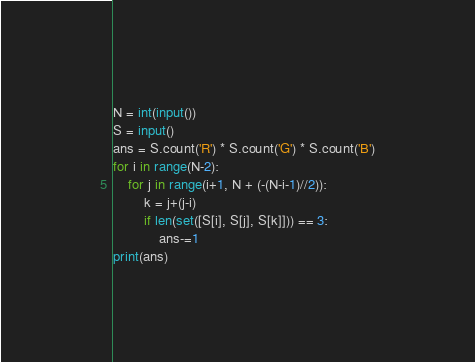Convert code to text. <code><loc_0><loc_0><loc_500><loc_500><_Python_>N = int(input())
S = input()
ans = S.count('R') * S.count('G') * S.count('B')
for i in range(N-2):
    for j in range(i+1, N + (-(N-i-1)//2)):
        k = j+(j-i)
        if len(set([S[i], S[j], S[k]])) == 3:
            ans-=1
print(ans)</code> 